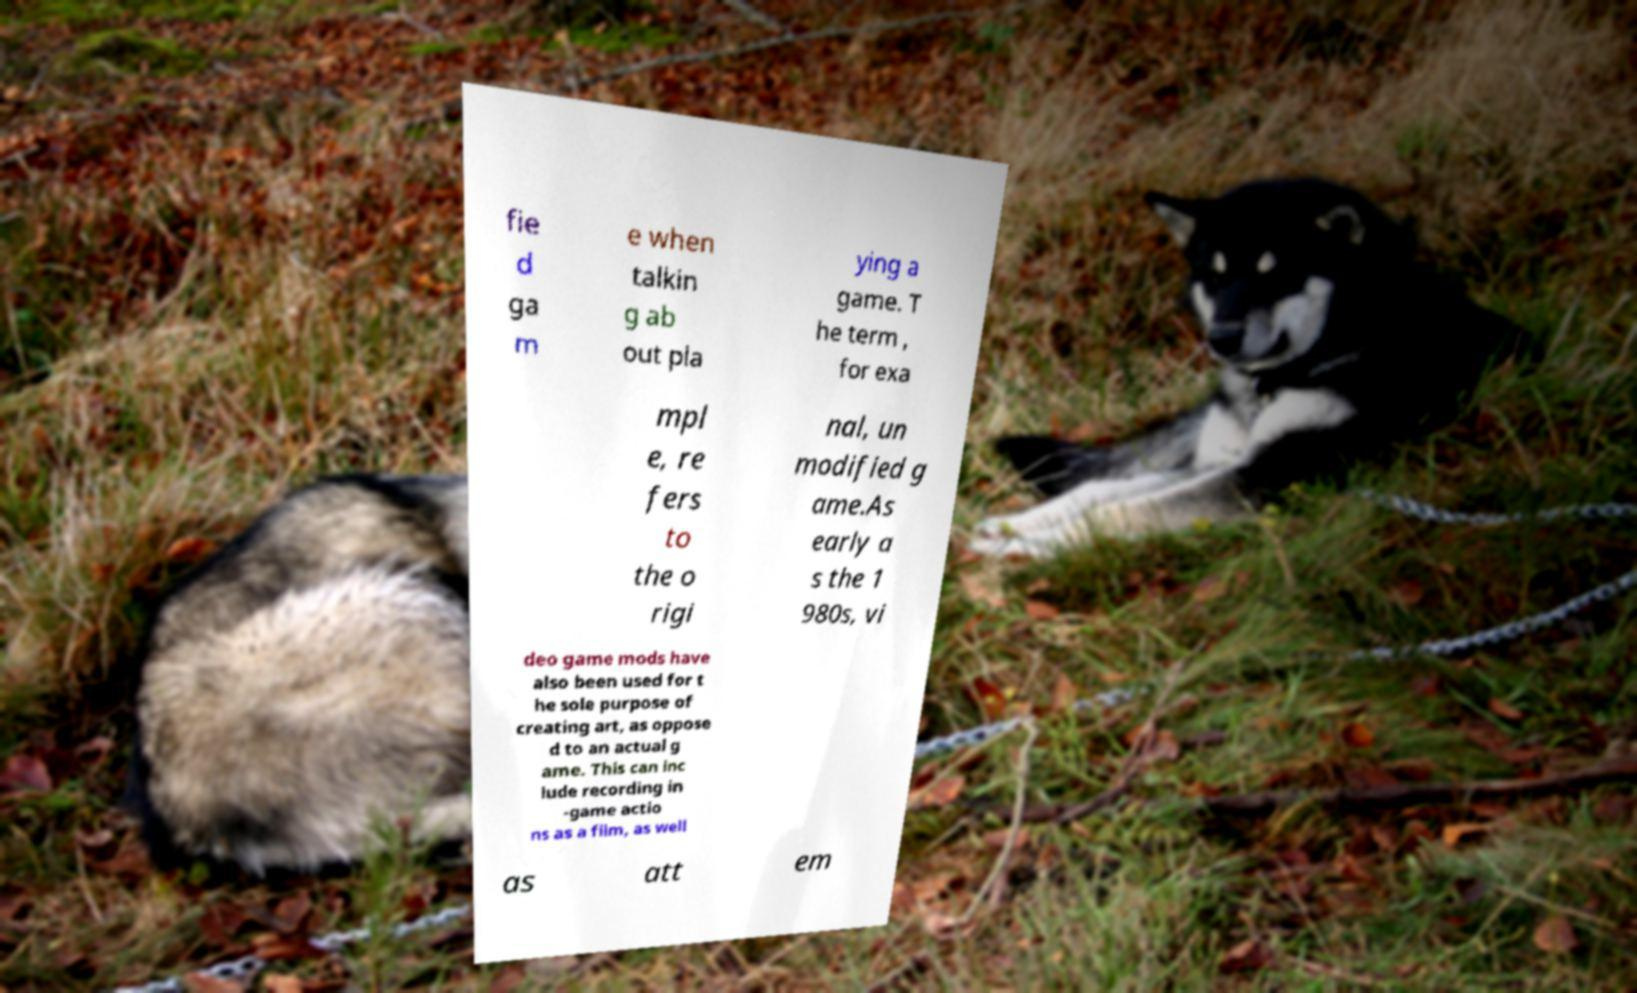I need the written content from this picture converted into text. Can you do that? fie d ga m e when talkin g ab out pla ying a game. T he term , for exa mpl e, re fers to the o rigi nal, un modified g ame.As early a s the 1 980s, vi deo game mods have also been used for t he sole purpose of creating art, as oppose d to an actual g ame. This can inc lude recording in -game actio ns as a film, as well as att em 